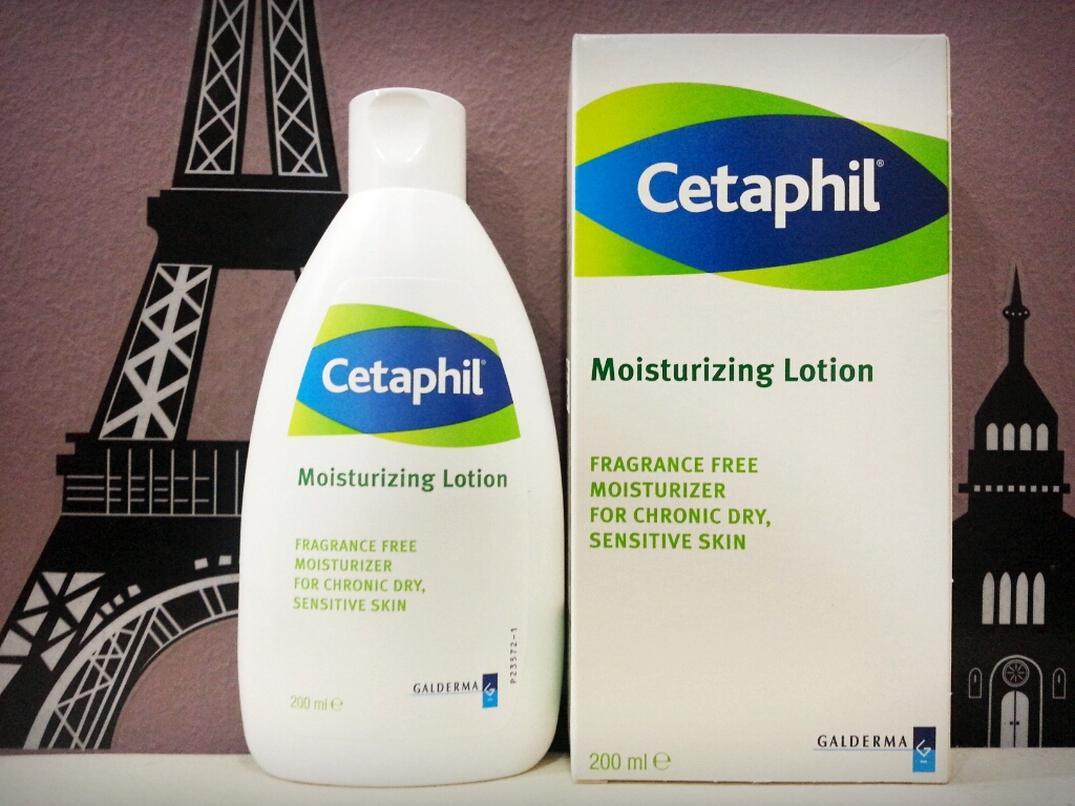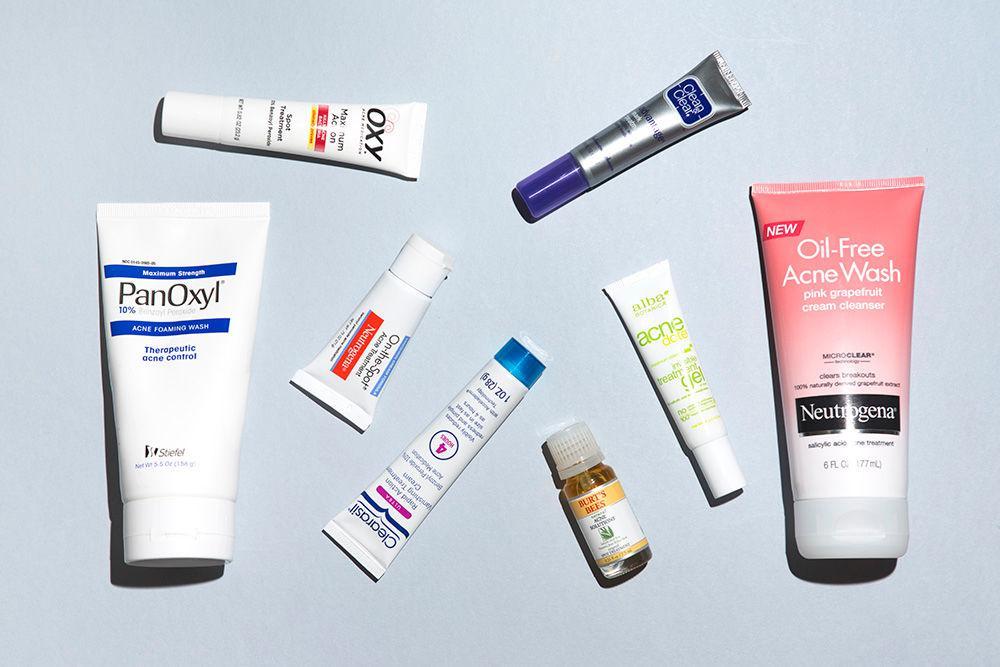The first image is the image on the left, the second image is the image on the right. Assess this claim about the two images: "At least one image contains no more than one lotion product outside of its box.". Correct or not? Answer yes or no. Yes. The first image is the image on the left, the second image is the image on the right. Analyze the images presented: Is the assertion "In each image, at least five different personal care products are arranged in a row so that all labels are showing." valid? Answer yes or no. No. 